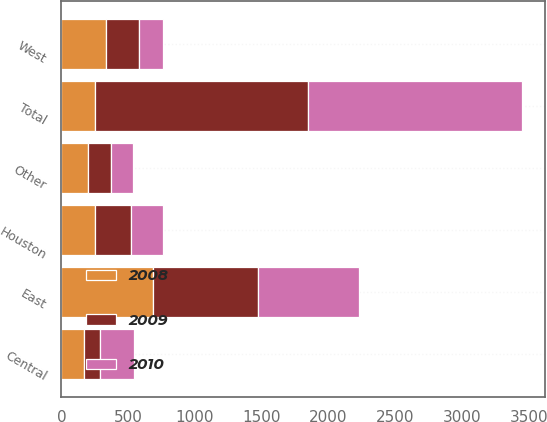Convert chart to OTSL. <chart><loc_0><loc_0><loc_500><loc_500><stacked_bar_chart><ecel><fcel>East<fcel>Central<fcel>West<fcel>Houston<fcel>Other<fcel>Total<nl><fcel>2010<fcel>757<fcel>254<fcel>179<fcel>245<fcel>169<fcel>1604<nl><fcel>2008<fcel>682<fcel>167<fcel>336<fcel>249<fcel>197<fcel>249<nl><fcel>2009<fcel>787<fcel>123<fcel>247<fcel>269<fcel>173<fcel>1599<nl></chart> 